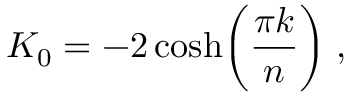Convert formula to latex. <formula><loc_0><loc_0><loc_500><loc_500>K _ { 0 } = - 2 \cosh \left ( { \frac { \pi k } { n } } \right ) \, ,</formula> 